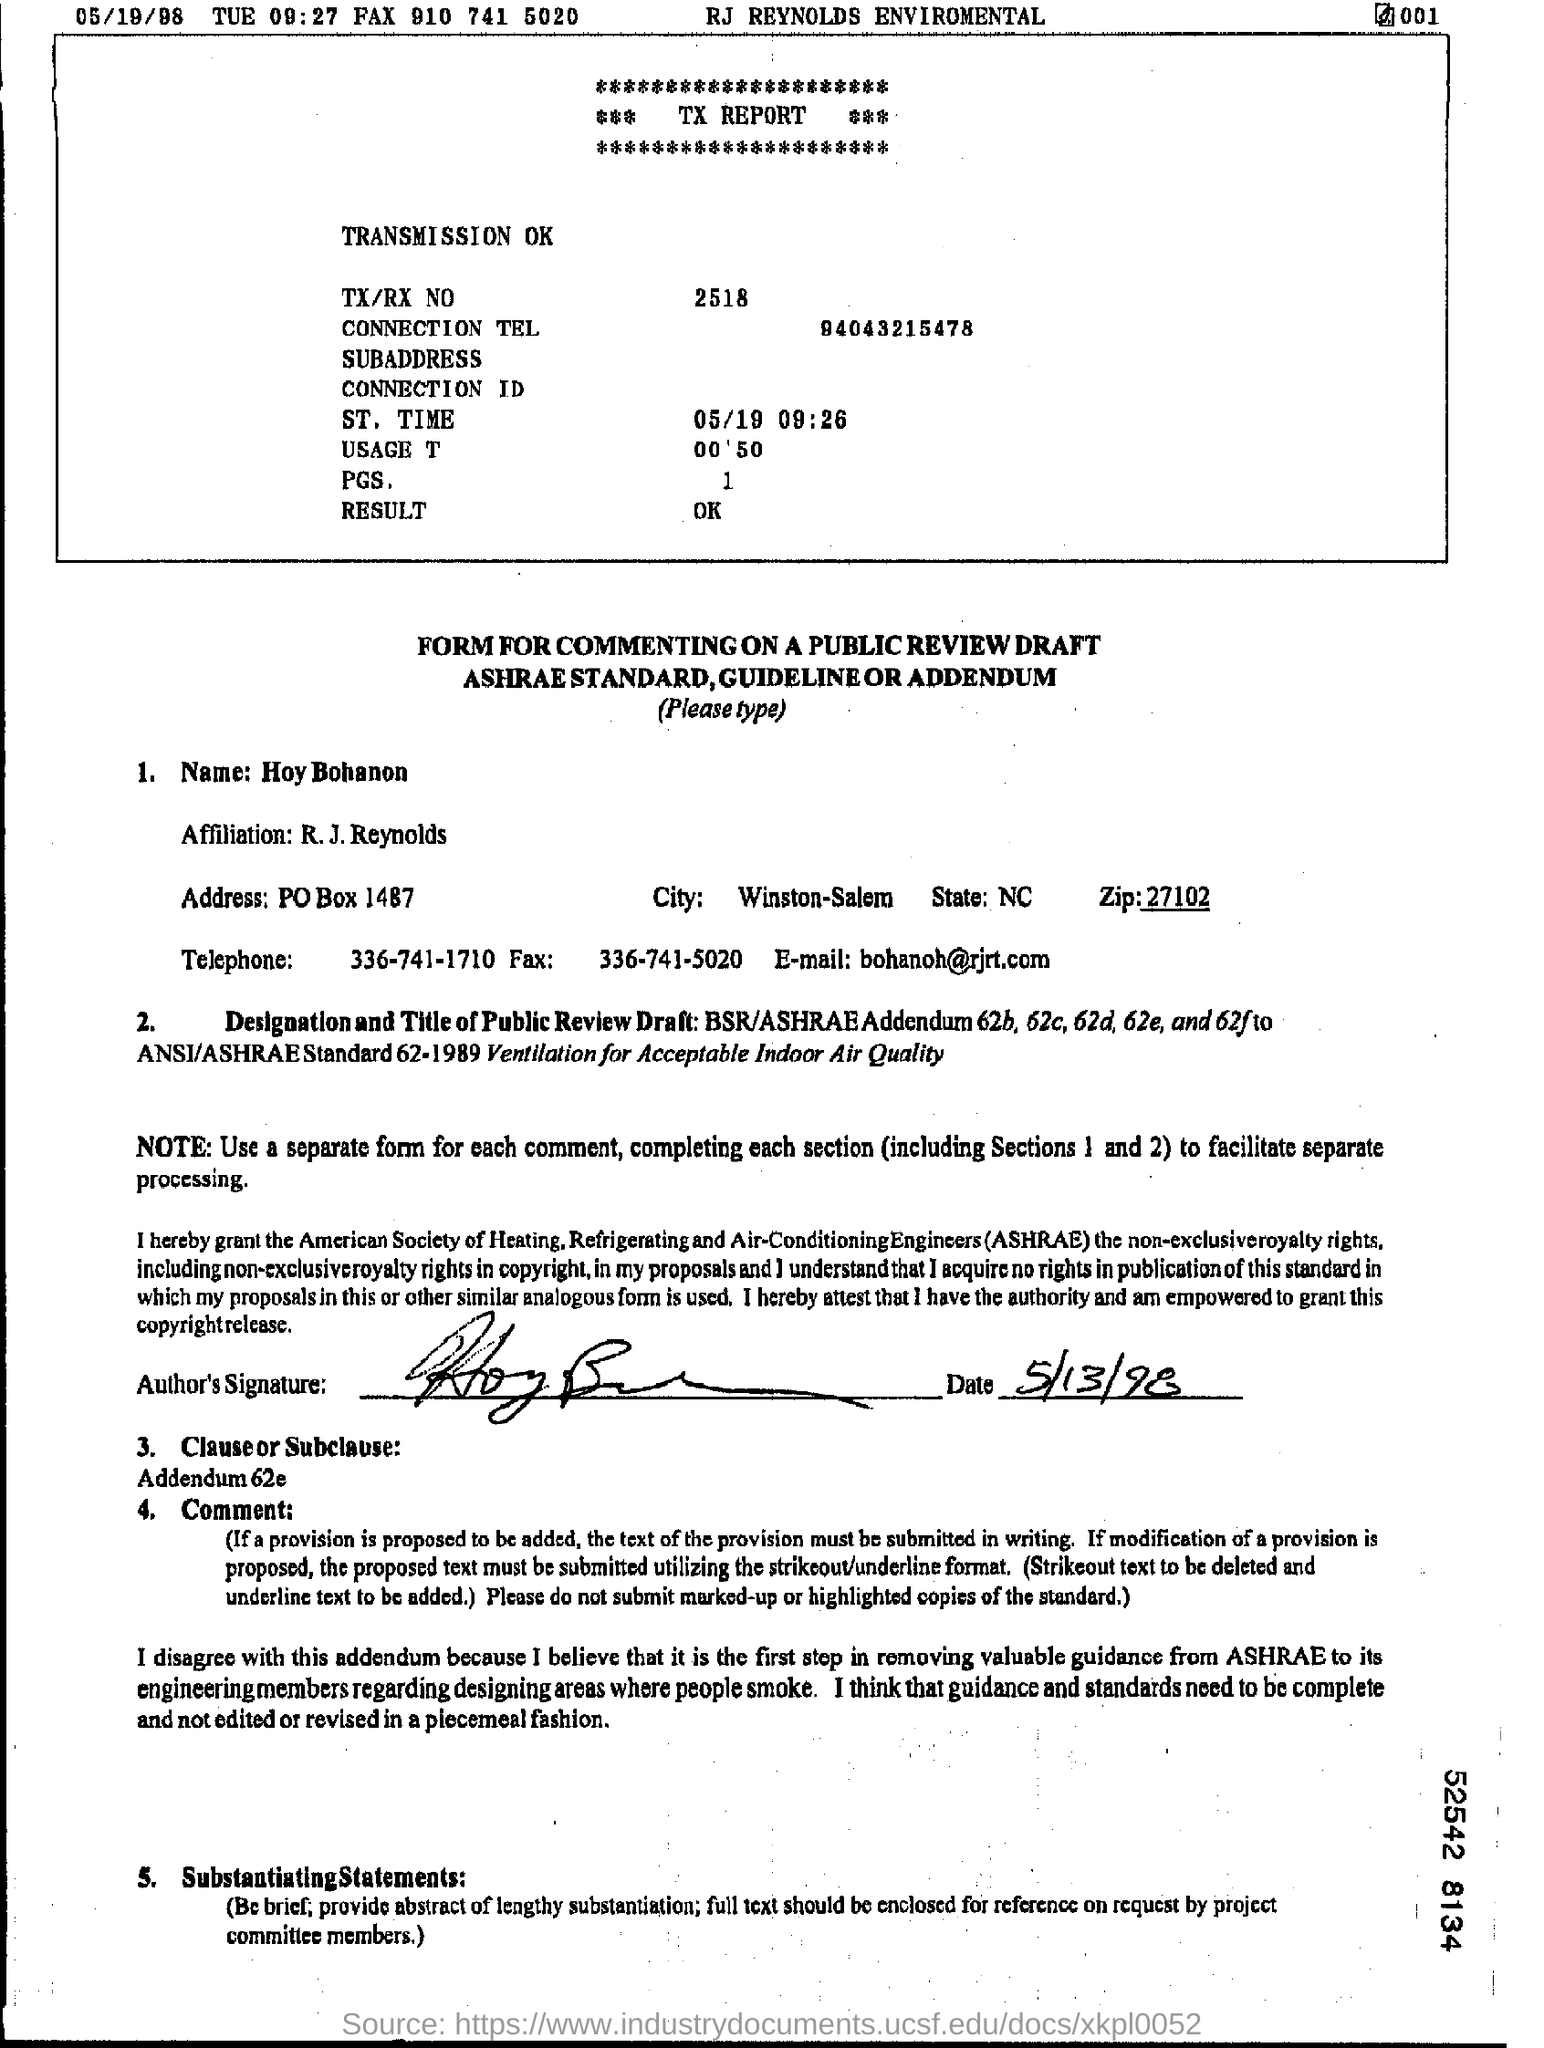What is the email id of the hoy bohanon ?
Offer a terse response. Bohanoh@rjrt.com. What is the telephone number of the hoy bohanon?
Your response must be concise. 336-741-1710. What is the connection tel number?
Your response must be concise. 94043215478. What is the tx/rx no?
Provide a short and direct response. 2518. 